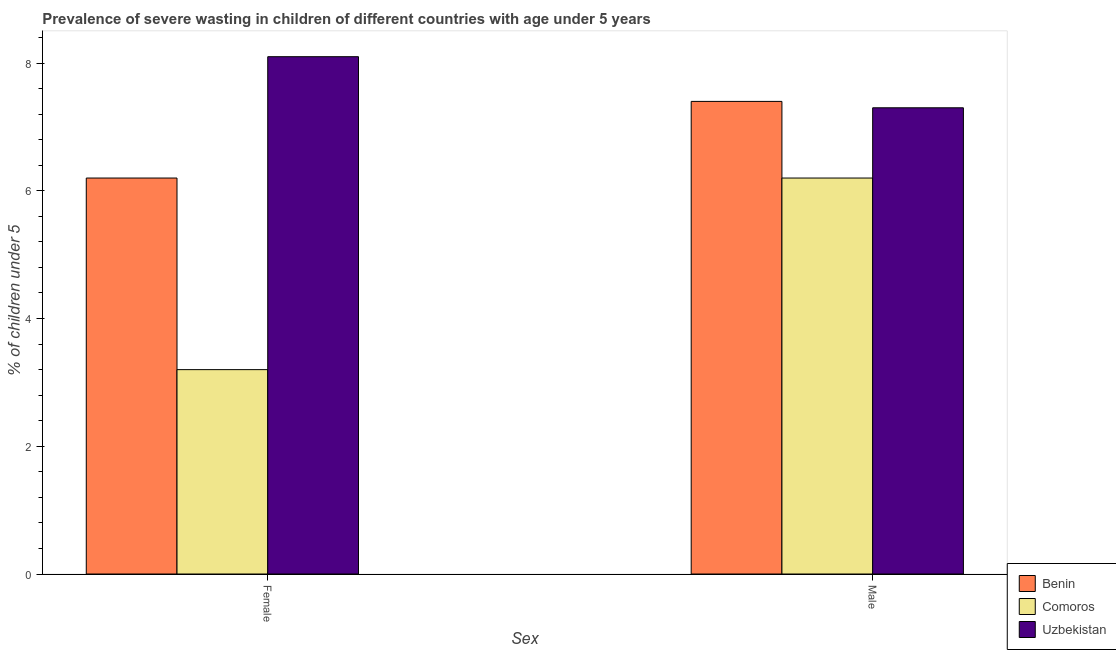How many different coloured bars are there?
Keep it short and to the point. 3. How many groups of bars are there?
Provide a succinct answer. 2. Are the number of bars per tick equal to the number of legend labels?
Offer a terse response. Yes. Are the number of bars on each tick of the X-axis equal?
Offer a very short reply. Yes. How many bars are there on the 2nd tick from the left?
Your answer should be compact. 3. How many bars are there on the 1st tick from the right?
Your response must be concise. 3. What is the percentage of undernourished female children in Uzbekistan?
Your response must be concise. 8.1. Across all countries, what is the maximum percentage of undernourished male children?
Provide a succinct answer. 7.4. Across all countries, what is the minimum percentage of undernourished female children?
Make the answer very short. 3.2. In which country was the percentage of undernourished female children maximum?
Keep it short and to the point. Uzbekistan. In which country was the percentage of undernourished male children minimum?
Provide a short and direct response. Comoros. What is the total percentage of undernourished male children in the graph?
Offer a terse response. 20.9. What is the difference between the percentage of undernourished female children in Uzbekistan and that in Comoros?
Provide a short and direct response. 4.9. What is the difference between the percentage of undernourished male children in Benin and the percentage of undernourished female children in Comoros?
Your answer should be very brief. 4.2. What is the average percentage of undernourished female children per country?
Make the answer very short. 5.83. What is the difference between the percentage of undernourished female children and percentage of undernourished male children in Comoros?
Provide a short and direct response. -3. What is the ratio of the percentage of undernourished female children in Uzbekistan to that in Benin?
Provide a succinct answer. 1.31. What does the 3rd bar from the left in Female represents?
Your answer should be compact. Uzbekistan. What does the 3rd bar from the right in Male represents?
Offer a terse response. Benin. How many bars are there?
Provide a short and direct response. 6. How many countries are there in the graph?
Offer a terse response. 3. Does the graph contain any zero values?
Your answer should be compact. No. Where does the legend appear in the graph?
Your answer should be compact. Bottom right. What is the title of the graph?
Ensure brevity in your answer.  Prevalence of severe wasting in children of different countries with age under 5 years. What is the label or title of the X-axis?
Keep it short and to the point. Sex. What is the label or title of the Y-axis?
Provide a succinct answer.  % of children under 5. What is the  % of children under 5 of Benin in Female?
Your answer should be very brief. 6.2. What is the  % of children under 5 in Comoros in Female?
Keep it short and to the point. 3.2. What is the  % of children under 5 of Uzbekistan in Female?
Your response must be concise. 8.1. What is the  % of children under 5 of Benin in Male?
Give a very brief answer. 7.4. What is the  % of children under 5 of Comoros in Male?
Your answer should be compact. 6.2. What is the  % of children under 5 of Uzbekistan in Male?
Provide a succinct answer. 7.3. Across all Sex, what is the maximum  % of children under 5 of Benin?
Keep it short and to the point. 7.4. Across all Sex, what is the maximum  % of children under 5 of Comoros?
Offer a very short reply. 6.2. Across all Sex, what is the maximum  % of children under 5 in Uzbekistan?
Make the answer very short. 8.1. Across all Sex, what is the minimum  % of children under 5 in Benin?
Make the answer very short. 6.2. Across all Sex, what is the minimum  % of children under 5 in Comoros?
Your answer should be compact. 3.2. Across all Sex, what is the minimum  % of children under 5 of Uzbekistan?
Offer a terse response. 7.3. What is the total  % of children under 5 of Benin in the graph?
Give a very brief answer. 13.6. What is the total  % of children under 5 in Comoros in the graph?
Your response must be concise. 9.4. What is the difference between the  % of children under 5 of Benin in Female and that in Male?
Your answer should be very brief. -1.2. What is the difference between the  % of children under 5 in Comoros in Female and that in Male?
Keep it short and to the point. -3. What is the difference between the  % of children under 5 of Comoros in Female and the  % of children under 5 of Uzbekistan in Male?
Give a very brief answer. -4.1. What is the difference between the  % of children under 5 of Comoros and  % of children under 5 of Uzbekistan in Female?
Make the answer very short. -4.9. What is the ratio of the  % of children under 5 of Benin in Female to that in Male?
Make the answer very short. 0.84. What is the ratio of the  % of children under 5 in Comoros in Female to that in Male?
Your response must be concise. 0.52. What is the ratio of the  % of children under 5 in Uzbekistan in Female to that in Male?
Offer a very short reply. 1.11. What is the difference between the highest and the lowest  % of children under 5 of Benin?
Make the answer very short. 1.2. What is the difference between the highest and the lowest  % of children under 5 of Comoros?
Your response must be concise. 3. 